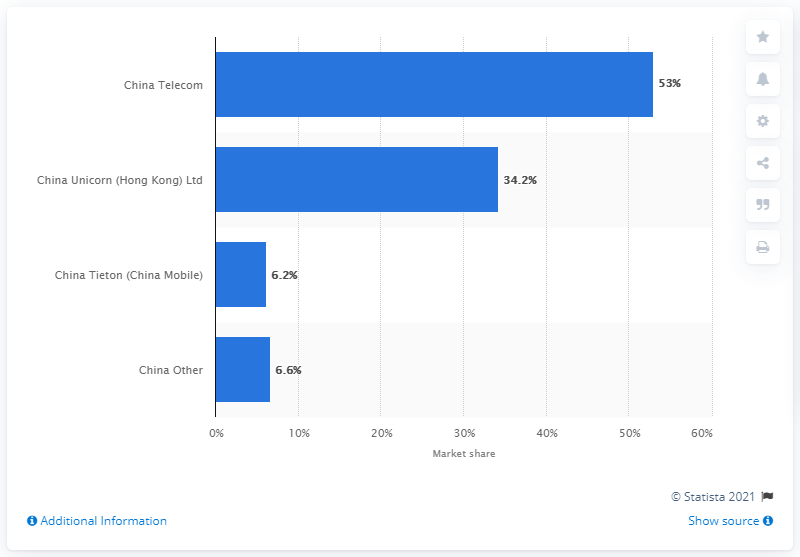Indicate a few pertinent items in this graphic. In the fourth quarter of 2013, China Telecom held a market share of approximately 53%. 